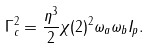<formula> <loc_0><loc_0><loc_500><loc_500>\Gamma _ { c } ^ { 2 } = \frac { \eta ^ { 3 } } { 2 } \chi ( 2 ) ^ { 2 } \omega _ { a } \omega _ { b } I _ { p } .</formula> 